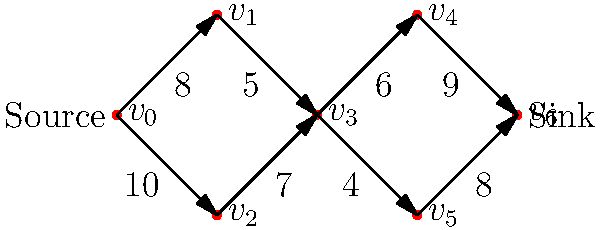In a plant's nutrient transport system modeled as a network flow problem, the above diagram represents the xylem vessels as edges and junctions as vertices. The edge capacities indicate the maximum flow rate (in μL/hour) of nutrients through each vessel. What is the maximum flow rate of nutrients from the source (roots) to the sink (leaves) in this plant system? To solve this maximum flow problem, we can use the Ford-Fulkerson algorithm:

1. Initialize flow to 0 for all edges.
2. Find an augmenting path from source to sink:
   Path 1: $v_0 \rightarrow v_1 \rightarrow v_3 \rightarrow v_4 \rightarrow v_6$ (min capacity = 5)
   Increase flow by 5.
3. Update residual graph and find another path:
   Path 2: $v_0 \rightarrow v_2 \rightarrow v_3 \rightarrow v_5 \rightarrow v_6$ (min capacity = 4)
   Increase flow by 4.
4. Update residual graph and find another path:
   Path 3: $v_0 \rightarrow v_1 \rightarrow v_3 \rightarrow v_5 \rightarrow v_6$ (min capacity = 3)
   Increase flow by 3.
5. Update residual graph and find another path:
   Path 4: $v_0 \rightarrow v_2 \rightarrow v_3 \rightarrow v_4 \rightarrow v_6$ (min capacity = 1)
   Increase flow by 1.
6. No more augmenting paths exist.

The maximum flow is the sum of all flow increases:
$$5 + 4 + 3 + 1 = 13 \text{ μL/hour}$$

This represents the maximum rate at which nutrients can be transported from the roots to the leaves in this plant system.
Answer: 13 μL/hour 